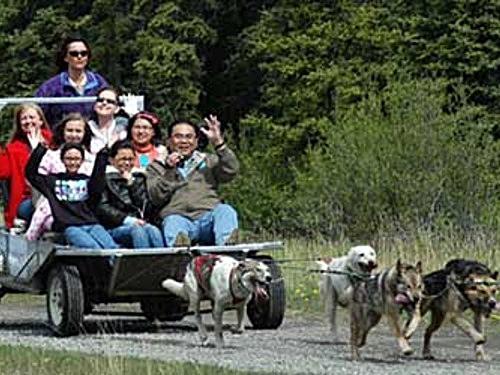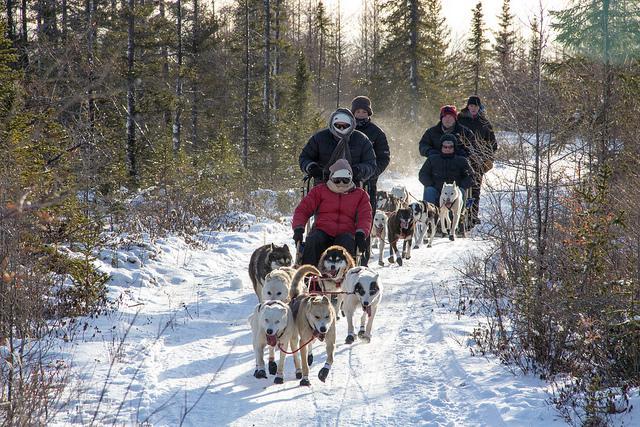The first image is the image on the left, the second image is the image on the right. Evaluate the accuracy of this statement regarding the images: "At least one image shows sled dogs moving across a snowy ground.". Is it true? Answer yes or no. Yes. The first image is the image on the left, the second image is the image on the right. Analyze the images presented: Is the assertion "Someone is riding a bike while dogs run with them." valid? Answer yes or no. No. 